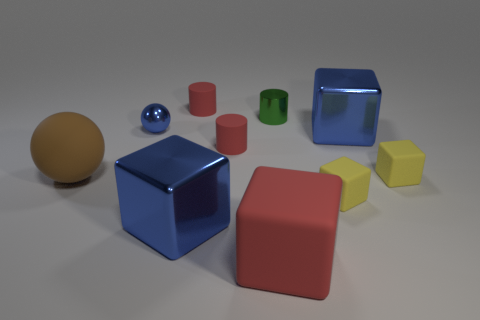How many big brown things have the same shape as the tiny green object?
Provide a short and direct response. 0. There is a green cylinder that is the same size as the metal ball; what material is it?
Provide a short and direct response. Metal. Are there any small yellow things made of the same material as the big brown object?
Offer a very short reply. Yes. Are there fewer brown rubber objects behind the brown matte sphere than big brown objects?
Give a very brief answer. Yes. What is the tiny cylinder that is behind the metallic thing behind the blue metal sphere made of?
Ensure brevity in your answer.  Rubber. The blue metal thing that is behind the rubber ball and on the left side of the green cylinder has what shape?
Keep it short and to the point. Sphere. How many other things are the same color as the small sphere?
Offer a very short reply. 2. What number of things are big blue things on the right side of the large red thing or large green spheres?
Your answer should be compact. 1. Do the large sphere and the tiny metal thing that is behind the blue metallic ball have the same color?
Give a very brief answer. No. Is there any other thing that has the same size as the red rubber cube?
Give a very brief answer. Yes. 